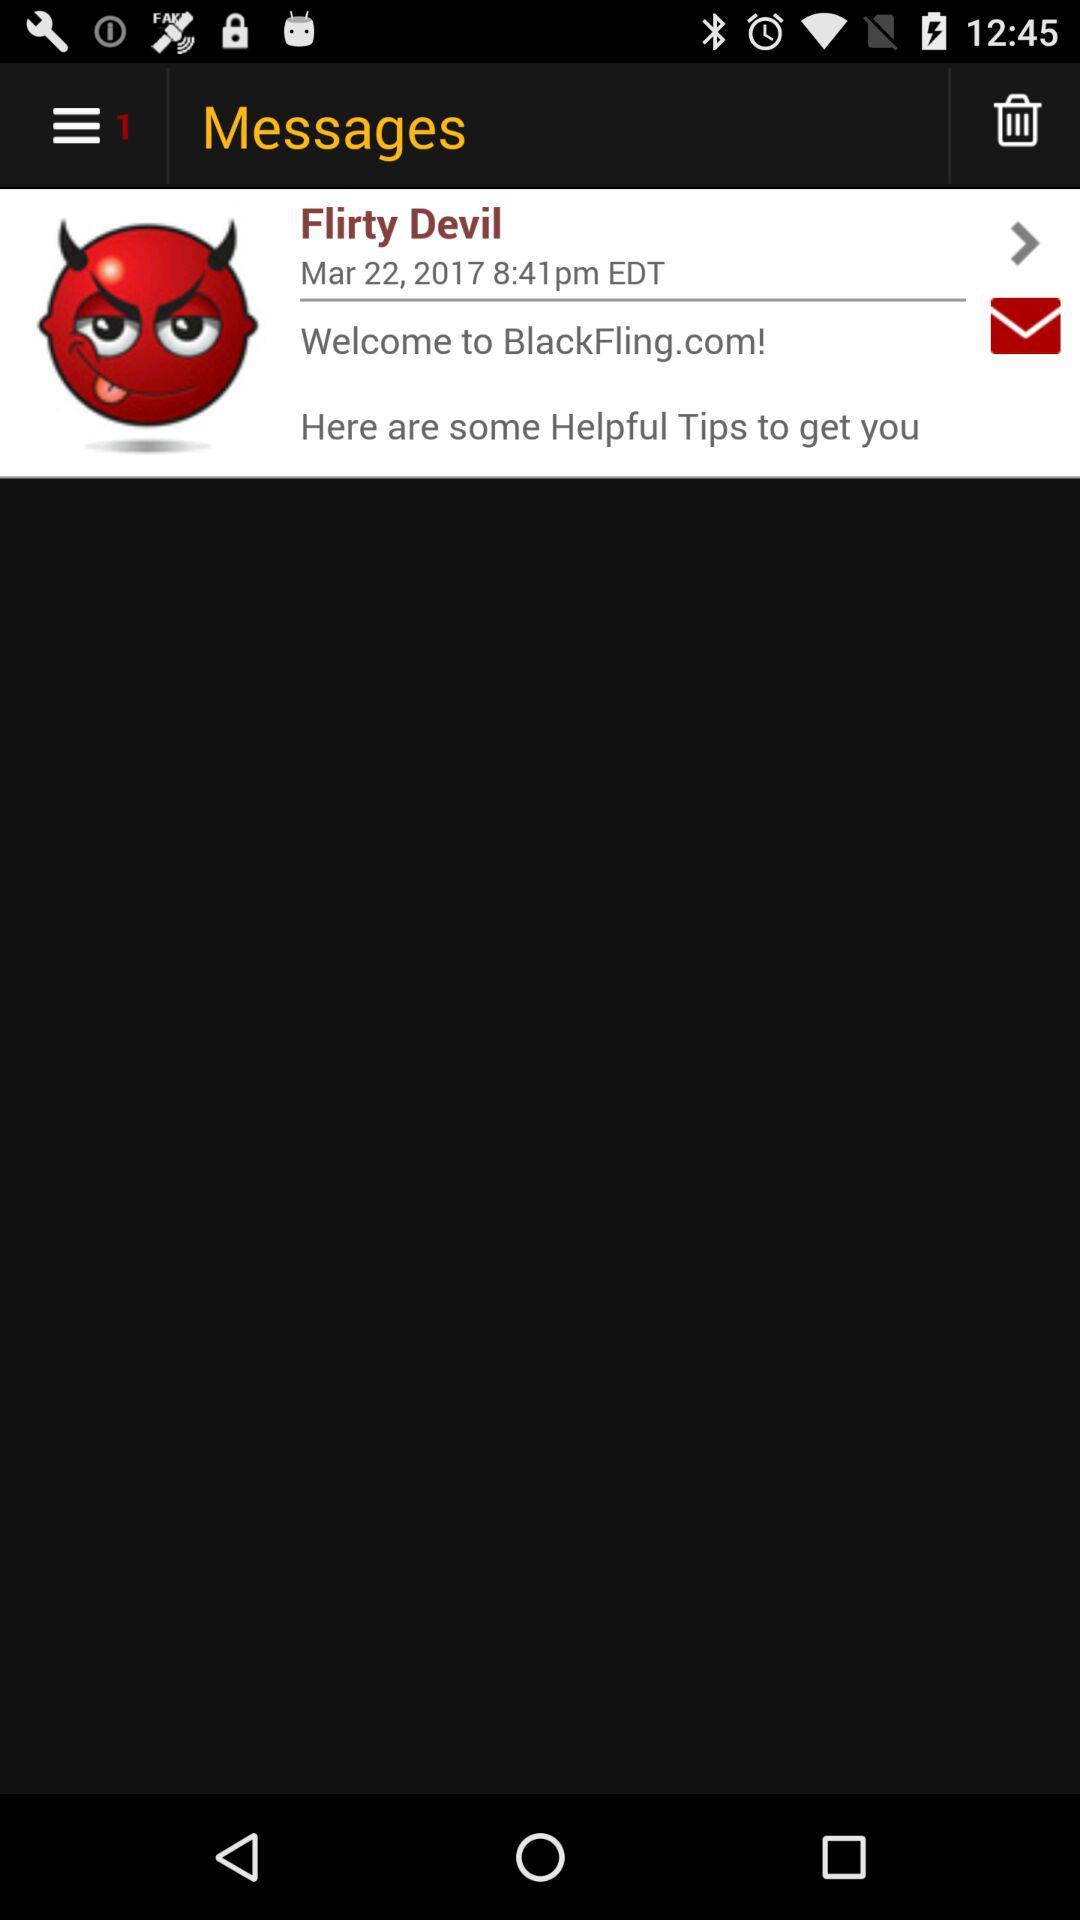Who is the sender of the message? The sender of the message is "Flirty Devil". 